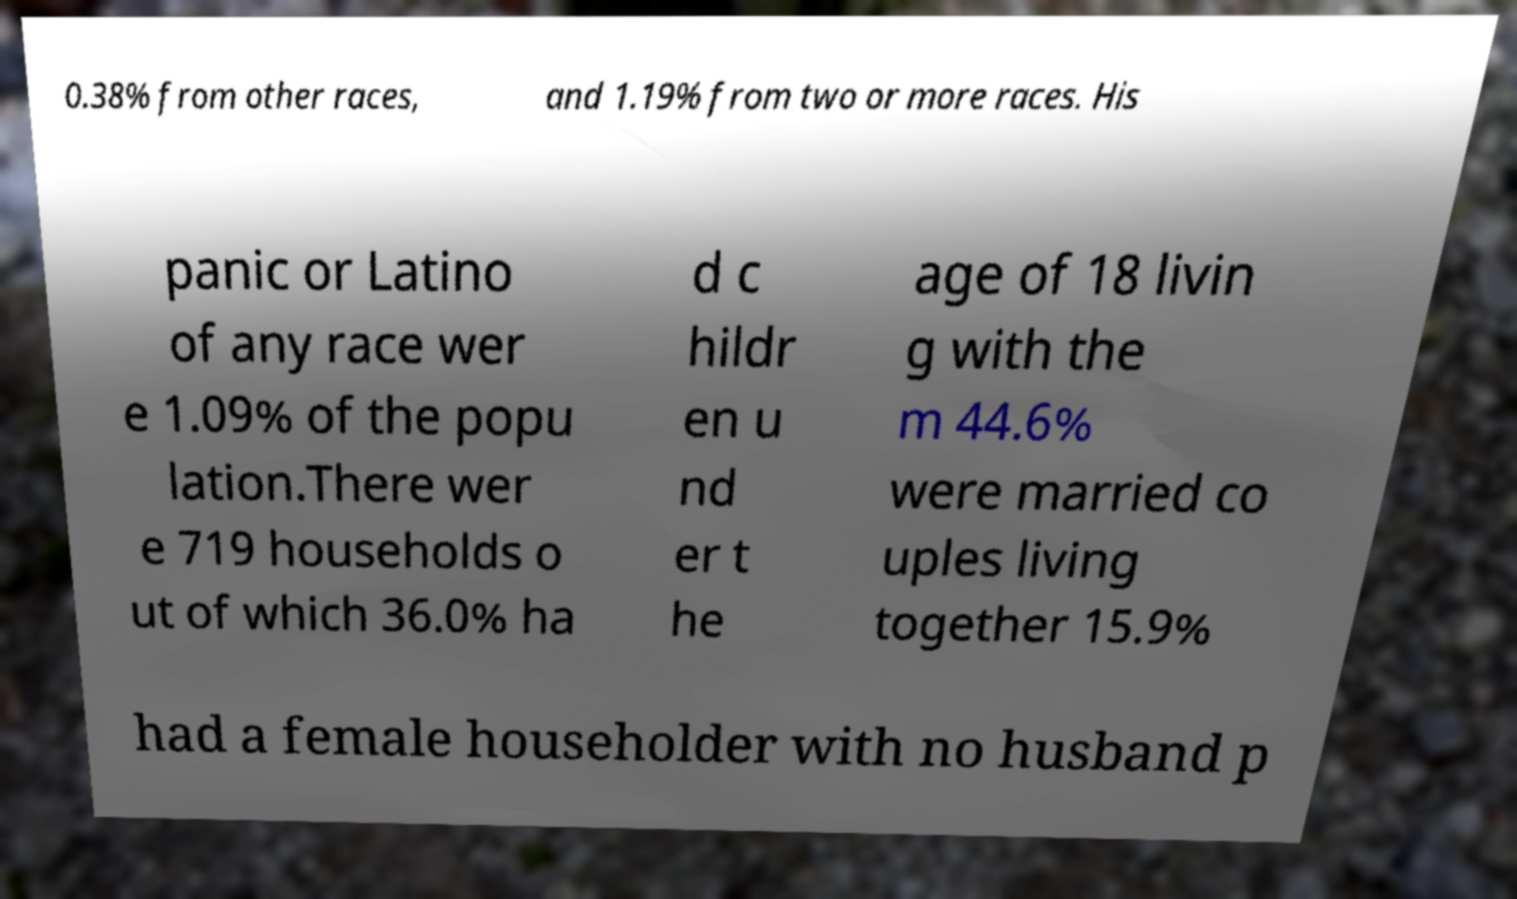There's text embedded in this image that I need extracted. Can you transcribe it verbatim? 0.38% from other races, and 1.19% from two or more races. His panic or Latino of any race wer e 1.09% of the popu lation.There wer e 719 households o ut of which 36.0% ha d c hildr en u nd er t he age of 18 livin g with the m 44.6% were married co uples living together 15.9% had a female householder with no husband p 